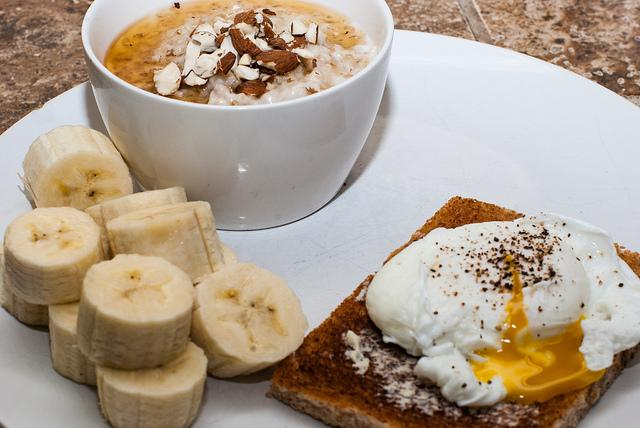What is this style of egg called? poached 